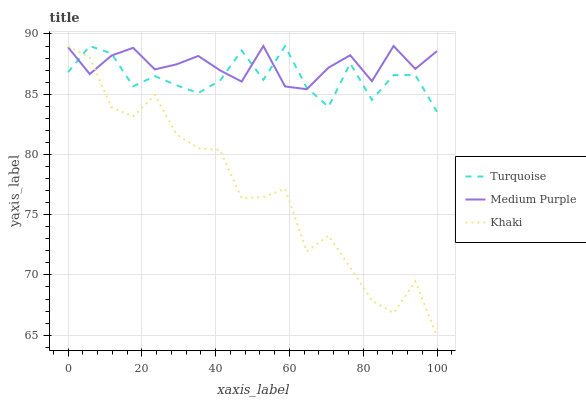Does Turquoise have the minimum area under the curve?
Answer yes or no. No. Does Turquoise have the maximum area under the curve?
Answer yes or no. No. Is Turquoise the smoothest?
Answer yes or no. No. Is Turquoise the roughest?
Answer yes or no. No. Does Turquoise have the lowest value?
Answer yes or no. No. 